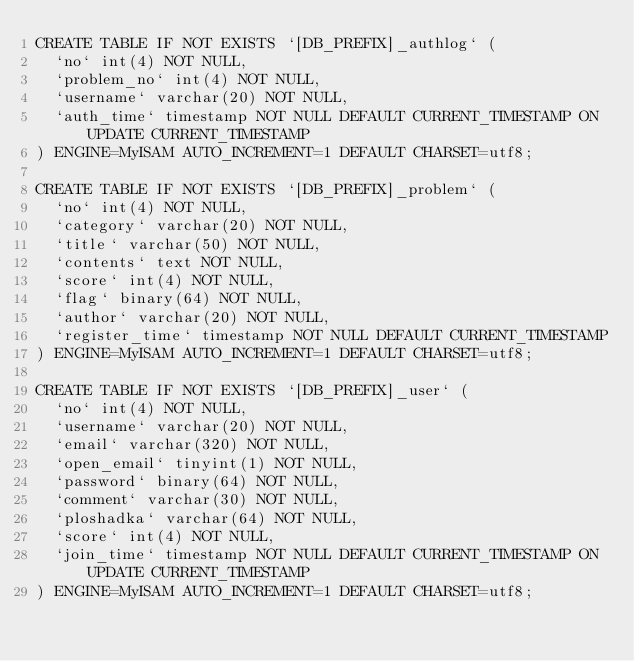Convert code to text. <code><loc_0><loc_0><loc_500><loc_500><_SQL_>CREATE TABLE IF NOT EXISTS `[DB_PREFIX]_authlog` (
	`no` int(4) NOT NULL,
	`problem_no` int(4) NOT NULL,
	`username` varchar(20) NOT NULL,
	`auth_time` timestamp NOT NULL DEFAULT CURRENT_TIMESTAMP ON UPDATE CURRENT_TIMESTAMP
) ENGINE=MyISAM AUTO_INCREMENT=1 DEFAULT CHARSET=utf8;

CREATE TABLE IF NOT EXISTS `[DB_PREFIX]_problem` (
	`no` int(4) NOT NULL,
	`category` varchar(20) NOT NULL,
	`title` varchar(50) NOT NULL,
	`contents` text NOT NULL,
	`score` int(4) NOT NULL,
	`flag` binary(64) NOT NULL,
	`author` varchar(20) NOT NULL,
	`register_time` timestamp NOT NULL DEFAULT CURRENT_TIMESTAMP
) ENGINE=MyISAM AUTO_INCREMENT=1 DEFAULT CHARSET=utf8;

CREATE TABLE IF NOT EXISTS `[DB_PREFIX]_user` (
	`no` int(4) NOT NULL,
	`username` varchar(20) NOT NULL,
	`email` varchar(320) NOT NULL,
	`open_email` tinyint(1) NOT NULL,
	`password` binary(64) NOT NULL,
	`comment` varchar(30) NOT NULL,
	`ploshadka` varchar(64) NOT NULL,
	`score` int(4) NOT NULL,
	`join_time` timestamp NOT NULL DEFAULT CURRENT_TIMESTAMP ON UPDATE CURRENT_TIMESTAMP
) ENGINE=MyISAM AUTO_INCREMENT=1 DEFAULT CHARSET=utf8;
</code> 